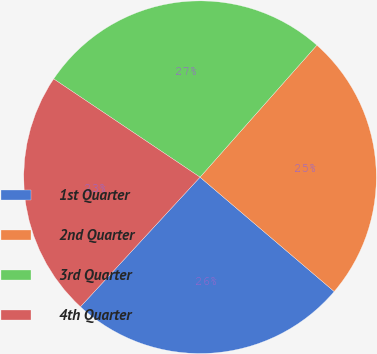Convert chart to OTSL. <chart><loc_0><loc_0><loc_500><loc_500><pie_chart><fcel>1st Quarter<fcel>2nd Quarter<fcel>3rd Quarter<fcel>4th Quarter<nl><fcel>25.63%<fcel>24.7%<fcel>27.12%<fcel>22.55%<nl></chart> 